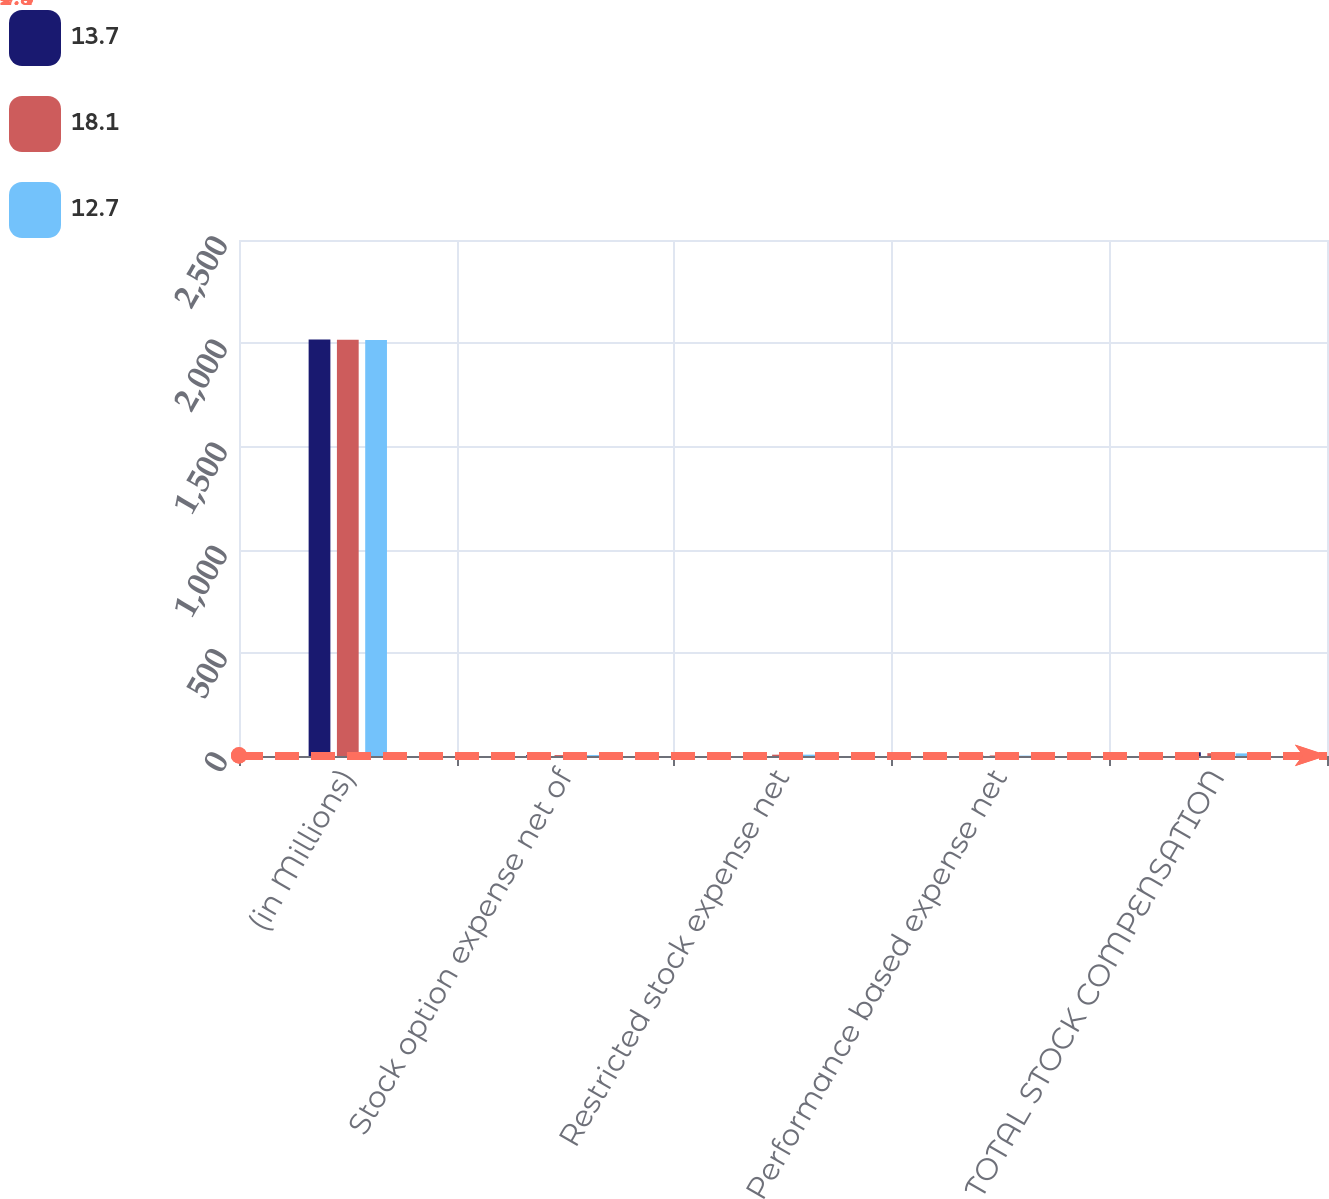<chart> <loc_0><loc_0><loc_500><loc_500><stacked_bar_chart><ecel><fcel>(in Millions)<fcel>Stock option expense net of<fcel>Restricted stock expense net<fcel>Performance based expense net<fcel>TOTAL STOCK COMPENSATION<nl><fcel>13.7<fcel>2018<fcel>4.9<fcel>8.4<fcel>4.4<fcel>18.1<nl><fcel>18.1<fcel>2017<fcel>4.5<fcel>6.4<fcel>2.8<fcel>13.7<nl><fcel>12.7<fcel>2016<fcel>4.4<fcel>6.5<fcel>1.8<fcel>12.7<nl></chart> 